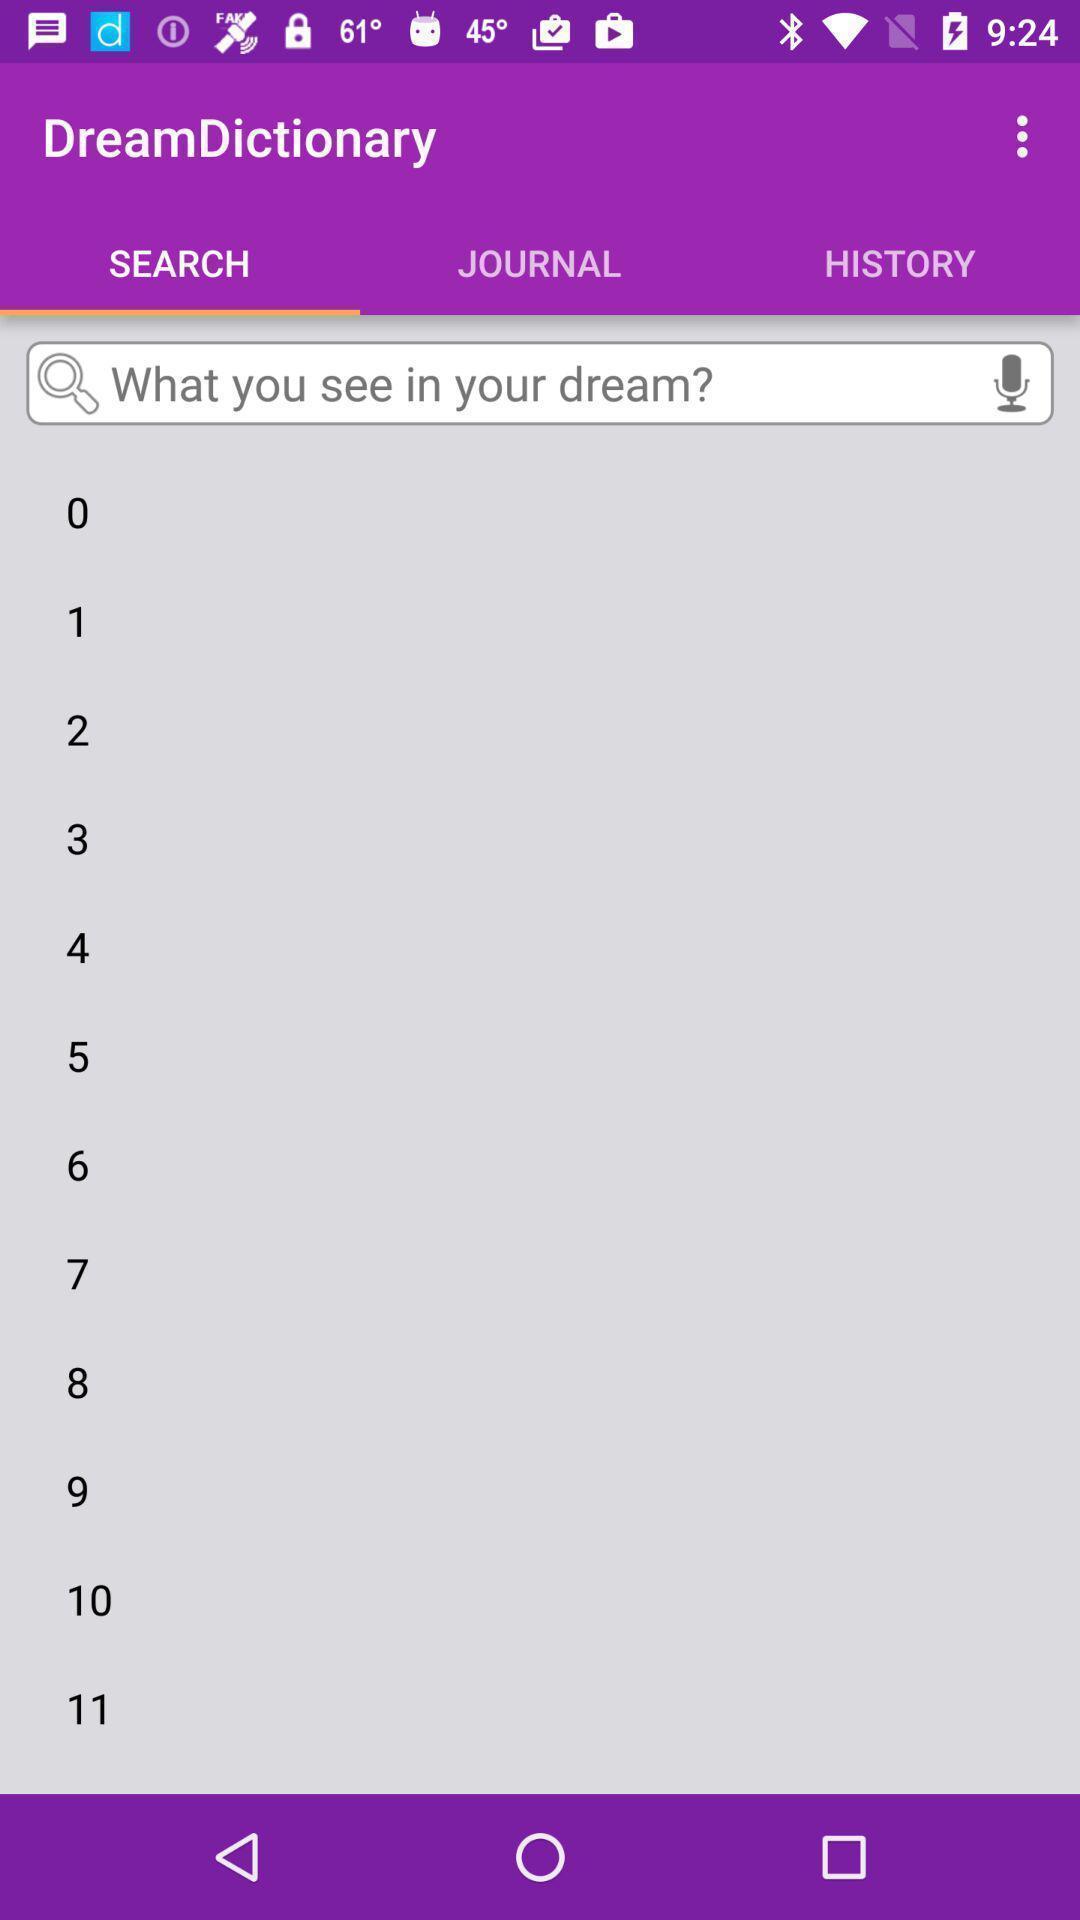Describe this image in words. Search bar to find your dream. 